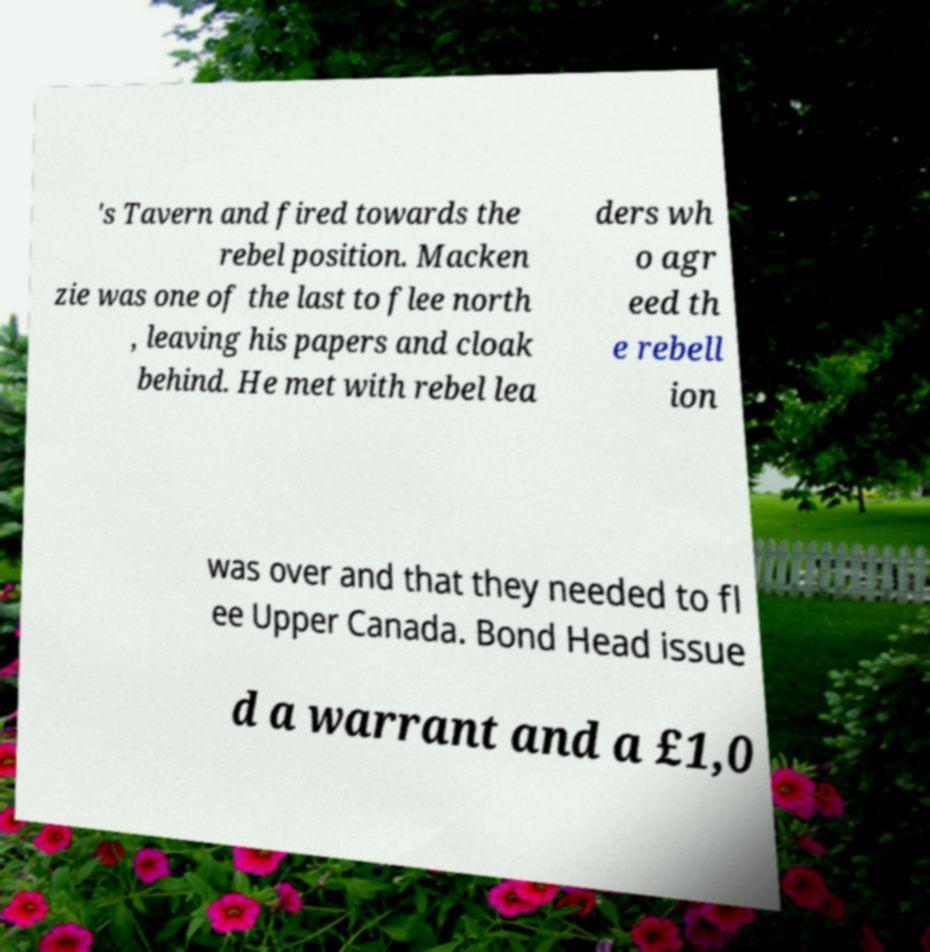There's text embedded in this image that I need extracted. Can you transcribe it verbatim? 's Tavern and fired towards the rebel position. Macken zie was one of the last to flee north , leaving his papers and cloak behind. He met with rebel lea ders wh o agr eed th e rebell ion was over and that they needed to fl ee Upper Canada. Bond Head issue d a warrant and a £1,0 